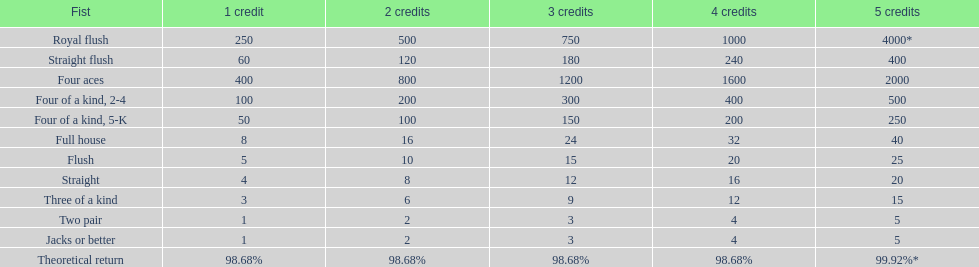What's the best type of four of a kind to win? Four of a kind, 2-4. 